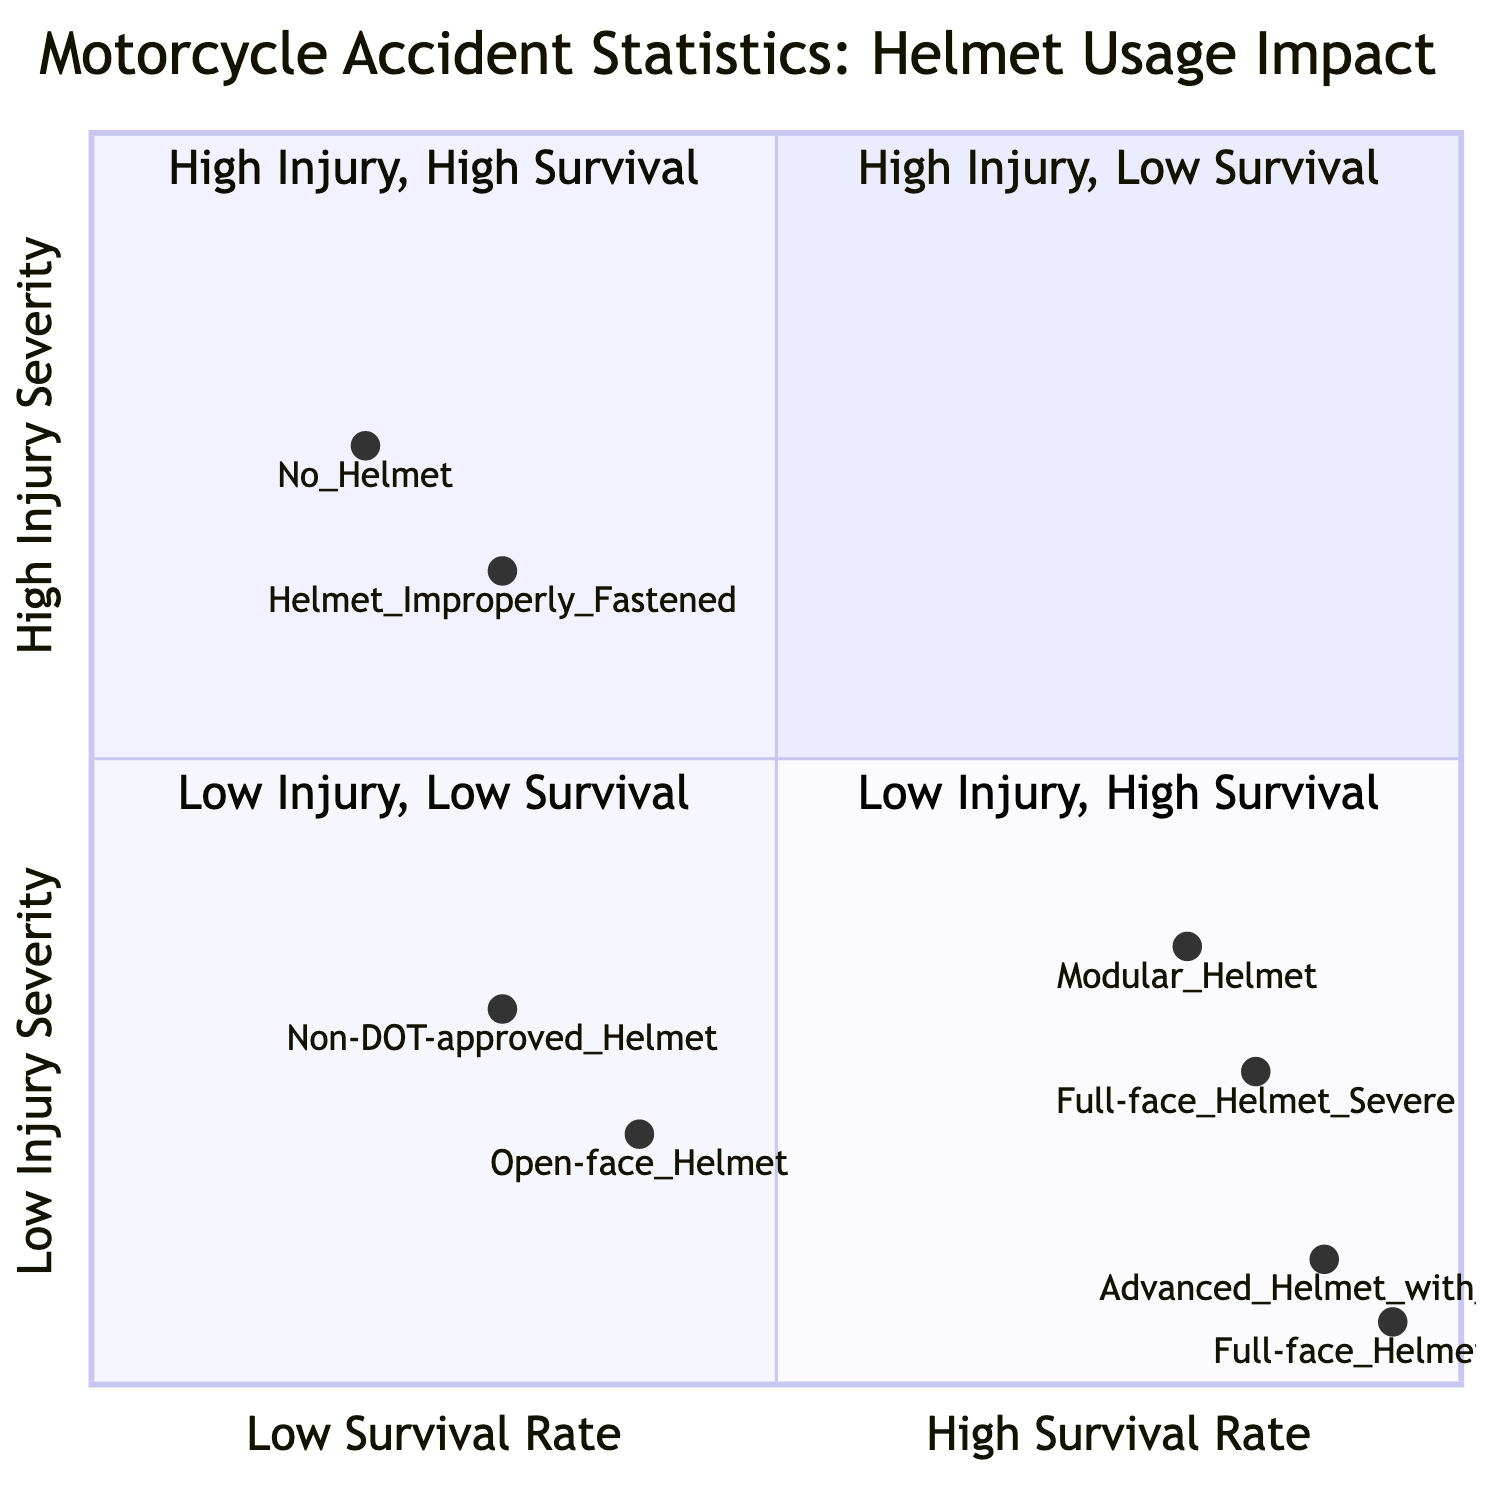What is the injury severity percentage for 'No Helmet'? The diagram shows that 'No Helmet' is located in the quadrant labelled 'High Injury Severity - Low Survival Rate'. According to the data, it has a statistic of '75% severe injuries'.
Answer: 75% severe injuries Which helmet type has the highest survival rate? Looking at the 'Low Injury Severity - High Survival Rate' quadrant, the 'Full-face Helmet' has a survival rate of '95%', which is higher than the other helmets depicted.
Answer: 95% How many helmet categories are represented in the diagram? By reviewing the quadrants, I can count the distinct helmet types shown, which include 'No Helmet', 'Helmet Improperly Fastened', 'Open-face Helmet', 'Non-DOT-approved Helmet', 'Full-face Helmet', and 'Modular Helmet', plus 'Advanced Helmet with EPS'. In total, there are six categories.
Answer: 6 What is the injury severity percentage for 'Modular Helmet'? In the 'High Injury Severity - High Survival Rate' quadrant, the 'Modular Helmet' shows '35% severe injuries'. This is the metric required to answer the question.
Answer: 35% severe injuries Which helmet shows the lowest injury severity percentage? The 'Full-face Helmet' in the 'Low Injury Severity - High Survival Rate' quadrant has '5% mild injuries', indicating it has the lowest injury severity percentage across all categories in the diagram.
Answer: 5% mild injuries What is the relationship between 'Full-face Helmet' and survival rates? The diagram presents two instances of 'Full-face Helmet': one in 'High Injury Severity - High Survival Rate' with an 85% survival rate and another in 'Low Injury Severity - High Survival Rate' with a 95% survival rate. This information indicates that the helmet is associated with high survival rates under different injury scenarios.
Answer: High survival rates What percentage of severe injuries is associated with improper helmet usage? The 'Helmet Improperly Fastened' in the 'High Injury Severity - Low Survival Rate' quadrant is associated with '65% severe injuries', indicating a significant impact on injury severity.
Answer: 65% severe injuries Which helmet type has a higher injury severity: Open-face Helmet or Non-DOT-approved Helmet? By comparing the injury severity percentages within the 'Low Injury Severity - Low Survival Rate' quadrant, 'Open-face Helmet' has '20% mild injuries' while 'Non-DOT-approved Helmet' has '30% mild injuries'. Therefore, 'Non-DOT-approved Helmet' has a higher injury severity percentage.
Answer: Non-DOT-approved Helmet What is the survival rate for 'Advanced Helmet with EPS'? Within the 'Low Injury Severity - High Survival Rate' quadrant, the 'Advanced Helmet with EPS' is indicated to have a '90% survival rate', providing the required information.
Answer: 90% survival rate 